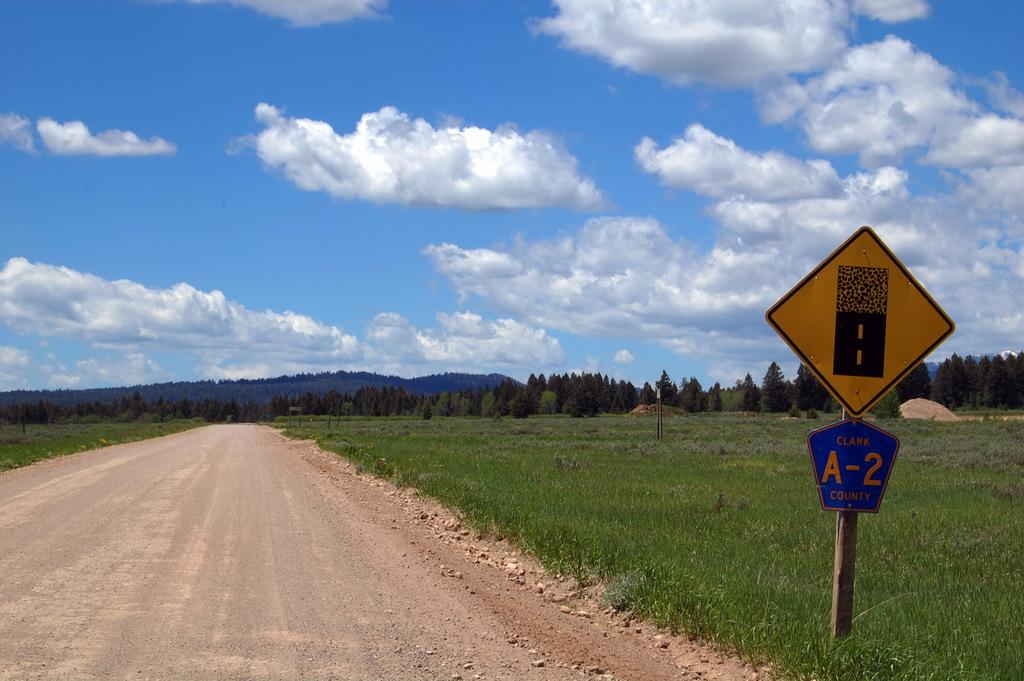<image>
Provide a brief description of the given image. A dirt road going to the trees is in Clark County. 